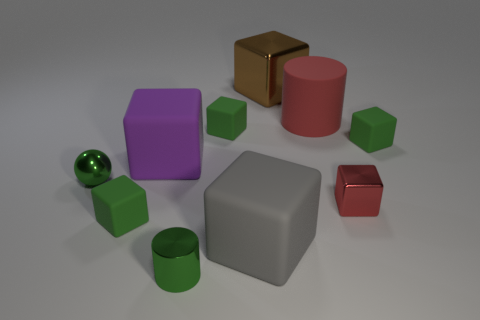How many green blocks must be subtracted to get 1 green blocks? 2 Subtract all big gray cubes. How many cubes are left? 6 Subtract all yellow spheres. How many green blocks are left? 3 Subtract all gray blocks. How many blocks are left? 6 Subtract all balls. How many objects are left? 9 Subtract all cubes. Subtract all big brown metal balls. How many objects are left? 3 Add 8 large brown shiny objects. How many large brown shiny objects are left? 9 Add 7 small brown spheres. How many small brown spheres exist? 7 Subtract 1 gray cubes. How many objects are left? 9 Subtract all blue cubes. Subtract all cyan cylinders. How many cubes are left? 7 